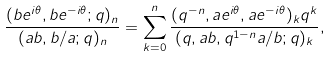Convert formula to latex. <formula><loc_0><loc_0><loc_500><loc_500>\frac { ( b e ^ { i \theta } , b e ^ { - i \theta } ; q ) _ { n } } { ( a b , b / a ; q ) _ { n } } & = \sum _ { k = 0 } ^ { n } \frac { ( q ^ { - n } , a e ^ { i \theta } , a e ^ { - i \theta } ) _ { k } q ^ { k } } { ( q , a b , q ^ { 1 - n } a / b ; q ) _ { k } } ,</formula> 